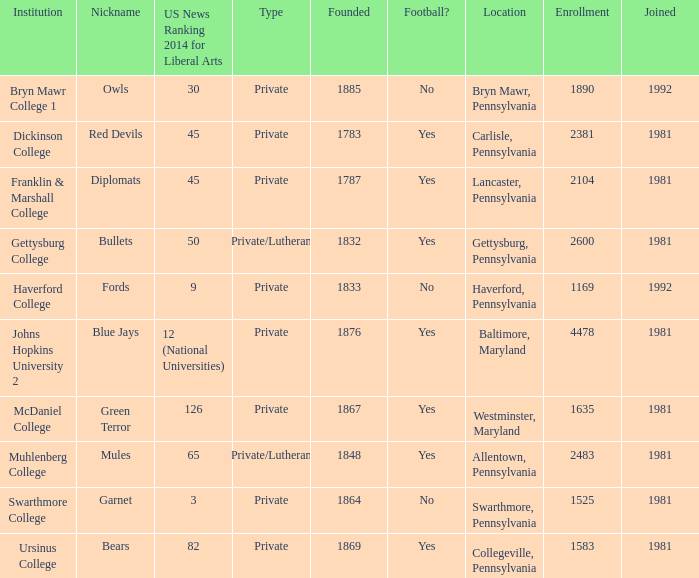When was Dickinson College founded? 1783.0. 